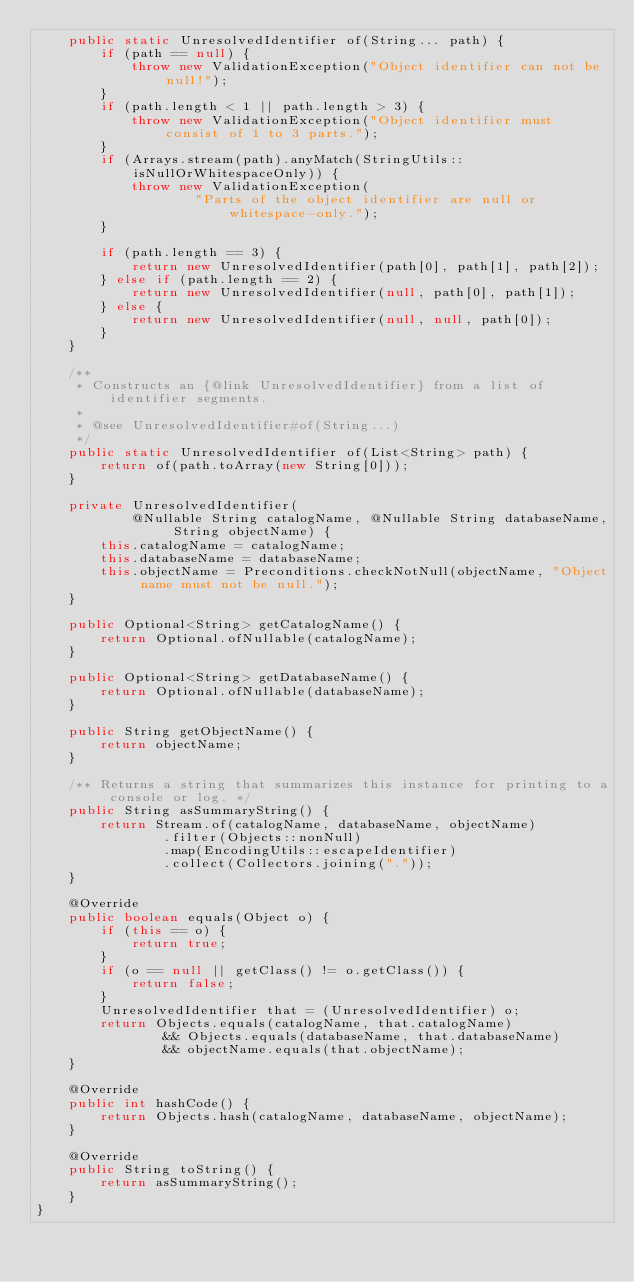<code> <loc_0><loc_0><loc_500><loc_500><_Java_>    public static UnresolvedIdentifier of(String... path) {
        if (path == null) {
            throw new ValidationException("Object identifier can not be null!");
        }
        if (path.length < 1 || path.length > 3) {
            throw new ValidationException("Object identifier must consist of 1 to 3 parts.");
        }
        if (Arrays.stream(path).anyMatch(StringUtils::isNullOrWhitespaceOnly)) {
            throw new ValidationException(
                    "Parts of the object identifier are null or whitespace-only.");
        }

        if (path.length == 3) {
            return new UnresolvedIdentifier(path[0], path[1], path[2]);
        } else if (path.length == 2) {
            return new UnresolvedIdentifier(null, path[0], path[1]);
        } else {
            return new UnresolvedIdentifier(null, null, path[0]);
        }
    }

    /**
     * Constructs an {@link UnresolvedIdentifier} from a list of identifier segments.
     *
     * @see UnresolvedIdentifier#of(String...)
     */
    public static UnresolvedIdentifier of(List<String> path) {
        return of(path.toArray(new String[0]));
    }

    private UnresolvedIdentifier(
            @Nullable String catalogName, @Nullable String databaseName, String objectName) {
        this.catalogName = catalogName;
        this.databaseName = databaseName;
        this.objectName = Preconditions.checkNotNull(objectName, "Object name must not be null.");
    }

    public Optional<String> getCatalogName() {
        return Optional.ofNullable(catalogName);
    }

    public Optional<String> getDatabaseName() {
        return Optional.ofNullable(databaseName);
    }

    public String getObjectName() {
        return objectName;
    }

    /** Returns a string that summarizes this instance for printing to a console or log. */
    public String asSummaryString() {
        return Stream.of(catalogName, databaseName, objectName)
                .filter(Objects::nonNull)
                .map(EncodingUtils::escapeIdentifier)
                .collect(Collectors.joining("."));
    }

    @Override
    public boolean equals(Object o) {
        if (this == o) {
            return true;
        }
        if (o == null || getClass() != o.getClass()) {
            return false;
        }
        UnresolvedIdentifier that = (UnresolvedIdentifier) o;
        return Objects.equals(catalogName, that.catalogName)
                && Objects.equals(databaseName, that.databaseName)
                && objectName.equals(that.objectName);
    }

    @Override
    public int hashCode() {
        return Objects.hash(catalogName, databaseName, objectName);
    }

    @Override
    public String toString() {
        return asSummaryString();
    }
}
</code> 